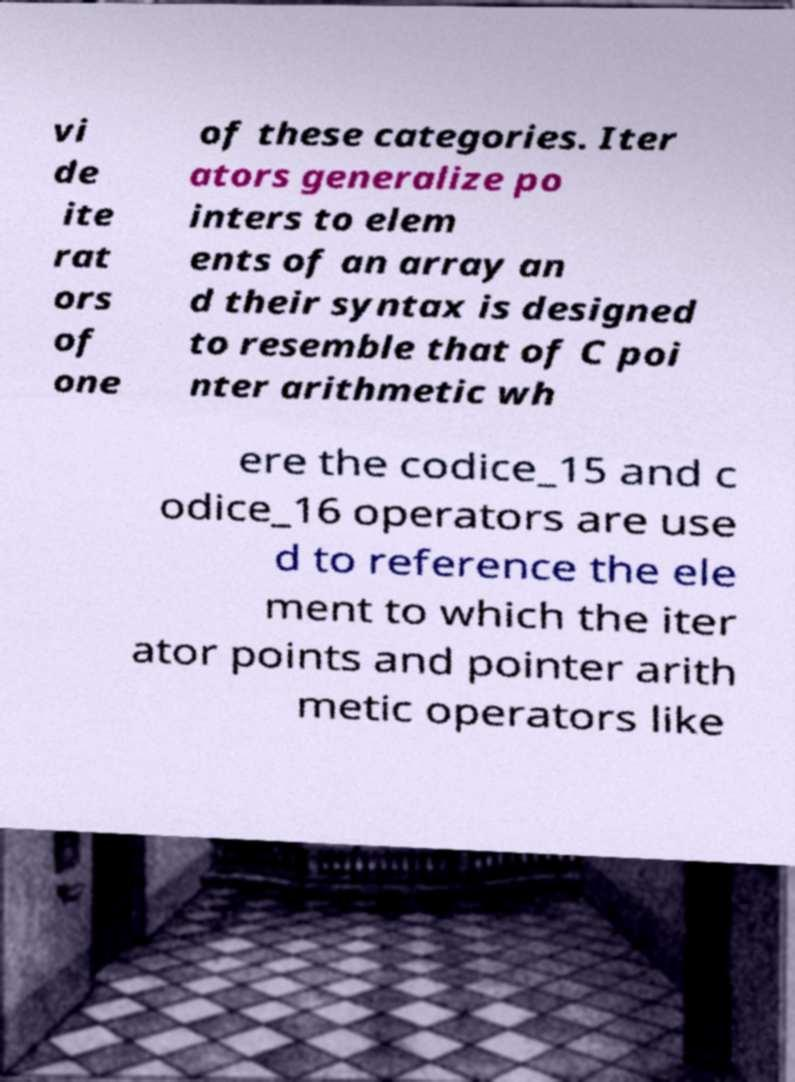Please identify and transcribe the text found in this image. vi de ite rat ors of one of these categories. Iter ators generalize po inters to elem ents of an array an d their syntax is designed to resemble that of C poi nter arithmetic wh ere the codice_15 and c odice_16 operators are use d to reference the ele ment to which the iter ator points and pointer arith metic operators like 